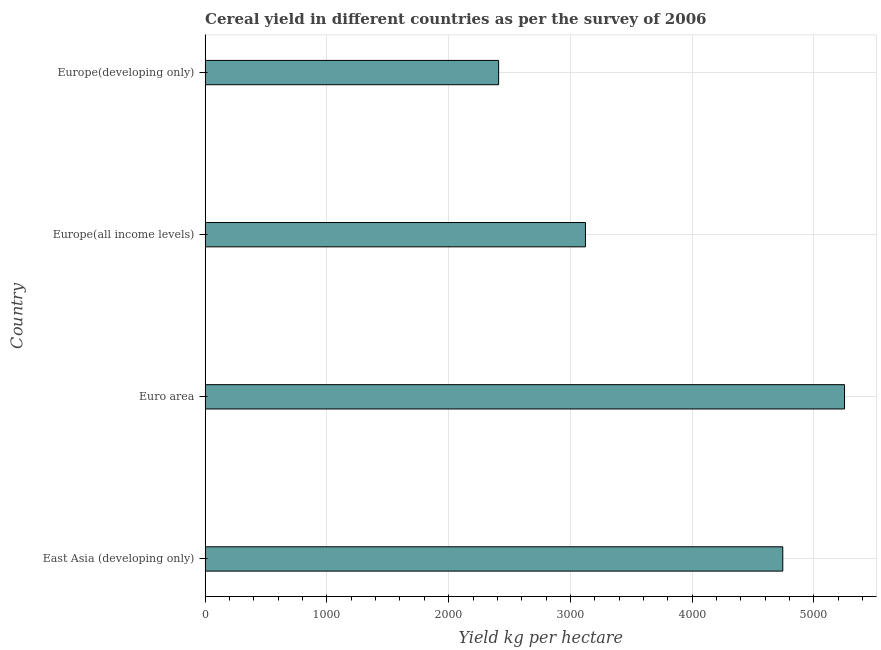Does the graph contain grids?
Your answer should be very brief. Yes. What is the title of the graph?
Ensure brevity in your answer.  Cereal yield in different countries as per the survey of 2006. What is the label or title of the X-axis?
Ensure brevity in your answer.  Yield kg per hectare. What is the label or title of the Y-axis?
Your answer should be compact. Country. What is the cereal yield in Euro area?
Your response must be concise. 5251.99. Across all countries, what is the maximum cereal yield?
Make the answer very short. 5251.99. Across all countries, what is the minimum cereal yield?
Your response must be concise. 2410.48. In which country was the cereal yield maximum?
Ensure brevity in your answer.  Euro area. In which country was the cereal yield minimum?
Provide a short and direct response. Europe(developing only). What is the sum of the cereal yield?
Offer a very short reply. 1.55e+04. What is the difference between the cereal yield in Europe(all income levels) and Europe(developing only)?
Provide a short and direct response. 713.21. What is the average cereal yield per country?
Provide a short and direct response. 3882.74. What is the median cereal yield?
Make the answer very short. 3934.24. In how many countries, is the cereal yield greater than 4400 kg per hectare?
Make the answer very short. 2. What is the ratio of the cereal yield in East Asia (developing only) to that in Europe(all income levels)?
Provide a short and direct response. 1.52. Is the cereal yield in East Asia (developing only) less than that in Euro area?
Offer a terse response. Yes. What is the difference between the highest and the second highest cereal yield?
Give a very brief answer. 507.19. Is the sum of the cereal yield in East Asia (developing only) and Europe(developing only) greater than the maximum cereal yield across all countries?
Make the answer very short. Yes. What is the difference between the highest and the lowest cereal yield?
Your answer should be very brief. 2841.5. How many bars are there?
Your answer should be compact. 4. Are all the bars in the graph horizontal?
Provide a short and direct response. Yes. What is the difference between two consecutive major ticks on the X-axis?
Keep it short and to the point. 1000. Are the values on the major ticks of X-axis written in scientific E-notation?
Your answer should be very brief. No. What is the Yield kg per hectare in East Asia (developing only)?
Offer a very short reply. 4744.79. What is the Yield kg per hectare of Euro area?
Provide a succinct answer. 5251.99. What is the Yield kg per hectare of Europe(all income levels)?
Provide a succinct answer. 3123.7. What is the Yield kg per hectare of Europe(developing only)?
Your answer should be very brief. 2410.48. What is the difference between the Yield kg per hectare in East Asia (developing only) and Euro area?
Offer a very short reply. -507.19. What is the difference between the Yield kg per hectare in East Asia (developing only) and Europe(all income levels)?
Offer a very short reply. 1621.1. What is the difference between the Yield kg per hectare in East Asia (developing only) and Europe(developing only)?
Your answer should be compact. 2334.31. What is the difference between the Yield kg per hectare in Euro area and Europe(all income levels)?
Make the answer very short. 2128.29. What is the difference between the Yield kg per hectare in Euro area and Europe(developing only)?
Offer a terse response. 2841.5. What is the difference between the Yield kg per hectare in Europe(all income levels) and Europe(developing only)?
Provide a succinct answer. 713.21. What is the ratio of the Yield kg per hectare in East Asia (developing only) to that in Euro area?
Keep it short and to the point. 0.9. What is the ratio of the Yield kg per hectare in East Asia (developing only) to that in Europe(all income levels)?
Provide a succinct answer. 1.52. What is the ratio of the Yield kg per hectare in East Asia (developing only) to that in Europe(developing only)?
Your answer should be compact. 1.97. What is the ratio of the Yield kg per hectare in Euro area to that in Europe(all income levels)?
Offer a terse response. 1.68. What is the ratio of the Yield kg per hectare in Euro area to that in Europe(developing only)?
Offer a terse response. 2.18. What is the ratio of the Yield kg per hectare in Europe(all income levels) to that in Europe(developing only)?
Provide a succinct answer. 1.3. 